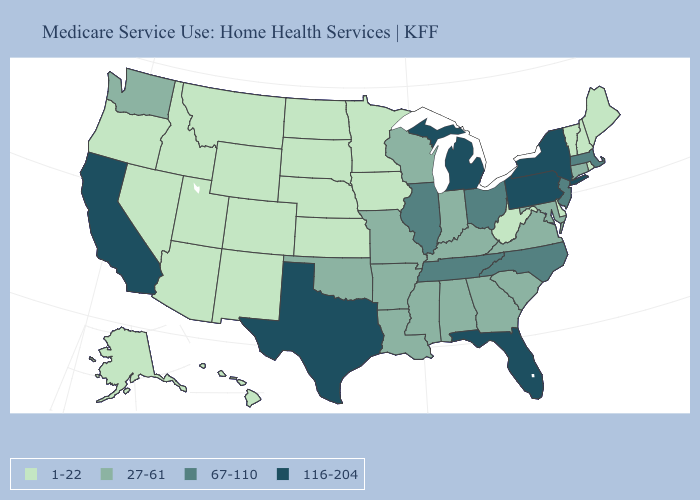Name the states that have a value in the range 27-61?
Quick response, please. Alabama, Arkansas, Connecticut, Georgia, Indiana, Kentucky, Louisiana, Maryland, Mississippi, Missouri, Oklahoma, South Carolina, Virginia, Washington, Wisconsin. What is the highest value in the South ?
Concise answer only. 116-204. What is the value of Maryland?
Quick response, please. 27-61. Which states hav the highest value in the MidWest?
Give a very brief answer. Michigan. What is the value of South Carolina?
Short answer required. 27-61. Which states have the highest value in the USA?
Give a very brief answer. California, Florida, Michigan, New York, Pennsylvania, Texas. Which states have the highest value in the USA?
Give a very brief answer. California, Florida, Michigan, New York, Pennsylvania, Texas. What is the value of Vermont?
Be succinct. 1-22. Does Hawaii have the same value as Pennsylvania?
Quick response, please. No. What is the value of Wyoming?
Keep it brief. 1-22. What is the highest value in states that border Montana?
Write a very short answer. 1-22. Does Washington have a lower value than Ohio?
Be succinct. Yes. What is the value of Missouri?
Be succinct. 27-61. Name the states that have a value in the range 67-110?
Quick response, please. Illinois, Massachusetts, New Jersey, North Carolina, Ohio, Tennessee. 